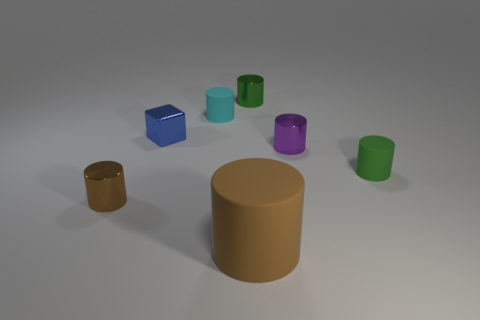What number of cylinders are on the right side of the small cyan rubber cylinder and in front of the small green rubber cylinder?
Offer a very short reply. 1. The cyan matte object that is the same size as the green metal cylinder is what shape?
Ensure brevity in your answer.  Cylinder. The block is what size?
Offer a terse response. Small. There is a brown object in front of the brown cylinder to the left of the block on the left side of the tiny cyan cylinder; what is its material?
Keep it short and to the point. Rubber. What color is the tiny block that is the same material as the small brown object?
Offer a terse response. Blue. There is a thing in front of the brown thing that is on the left side of the large brown matte cylinder; how many small brown metallic cylinders are behind it?
Keep it short and to the point. 1. What is the material of the tiny object that is the same color as the big thing?
Keep it short and to the point. Metal. Is there anything else that is the same shape as the purple object?
Your answer should be compact. Yes. What number of things are either tiny matte things that are behind the blue metal object or small yellow matte blocks?
Your response must be concise. 1. There is a big matte object that is right of the cyan cylinder; is it the same color as the block?
Make the answer very short. No. 